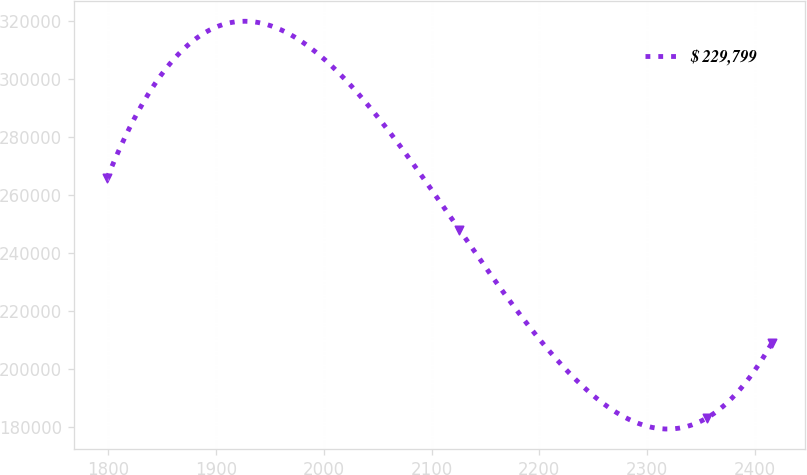Convert chart to OTSL. <chart><loc_0><loc_0><loc_500><loc_500><line_chart><ecel><fcel>$ 229,799<nl><fcel>1799<fcel>265863<nl><fcel>2125.78<fcel>248091<nl><fcel>2355.87<fcel>183311<nl><fcel>2415.89<fcel>209115<nl></chart> 